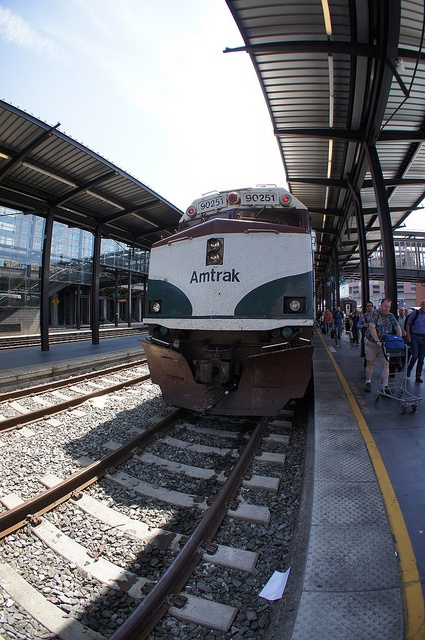Describe the objects in this image and their specific colors. I can see train in lightblue, black, darkgray, and gray tones, people in lightblue, black, gray, navy, and maroon tones, people in lightblue, black, navy, gray, and maroon tones, people in lightblue, black, navy, and gray tones, and backpack in lightblue, navy, black, darkblue, and blue tones in this image. 